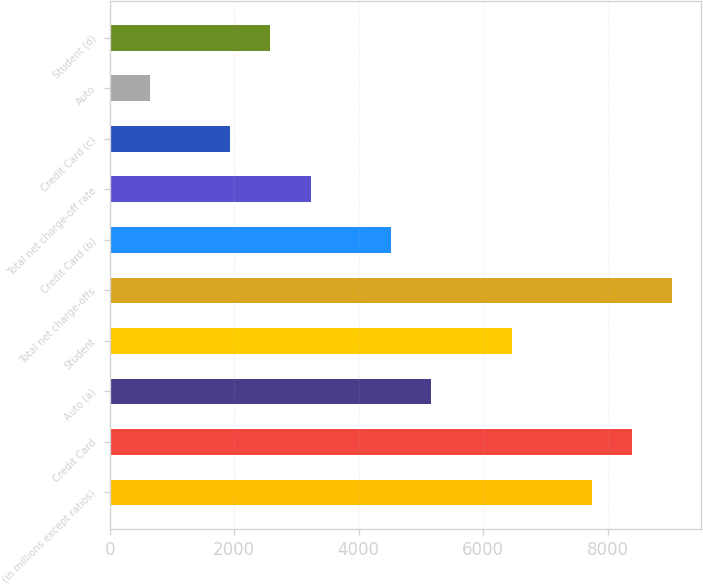Convert chart. <chart><loc_0><loc_0><loc_500><loc_500><bar_chart><fcel>(in millions except ratios)<fcel>Credit Card<fcel>Auto (a)<fcel>Student<fcel>Total net charge-offs<fcel>Credit Card (b)<fcel>Total net charge-off rate<fcel>Credit Card (c)<fcel>Auto<fcel>Student (d)<nl><fcel>7745.82<fcel>8391.22<fcel>5164.22<fcel>6455.02<fcel>9036.62<fcel>4518.82<fcel>3228.02<fcel>1937.22<fcel>646.42<fcel>2582.62<nl></chart> 